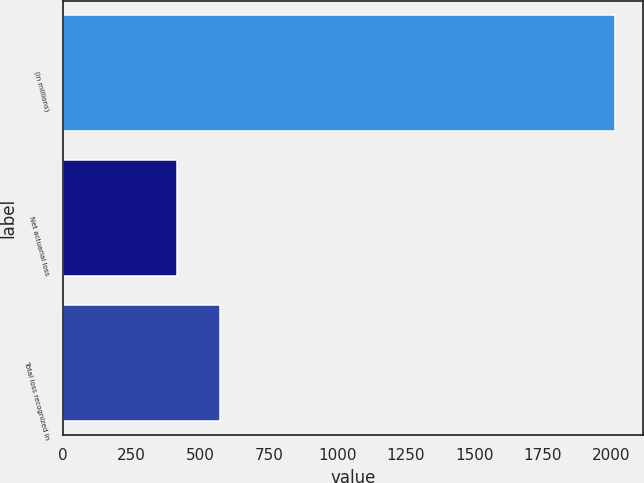Convert chart. <chart><loc_0><loc_0><loc_500><loc_500><bar_chart><fcel>(in millions)<fcel>Net actuarial loss<fcel>Total loss recognized in<nl><fcel>2013<fcel>414<fcel>573.9<nl></chart> 